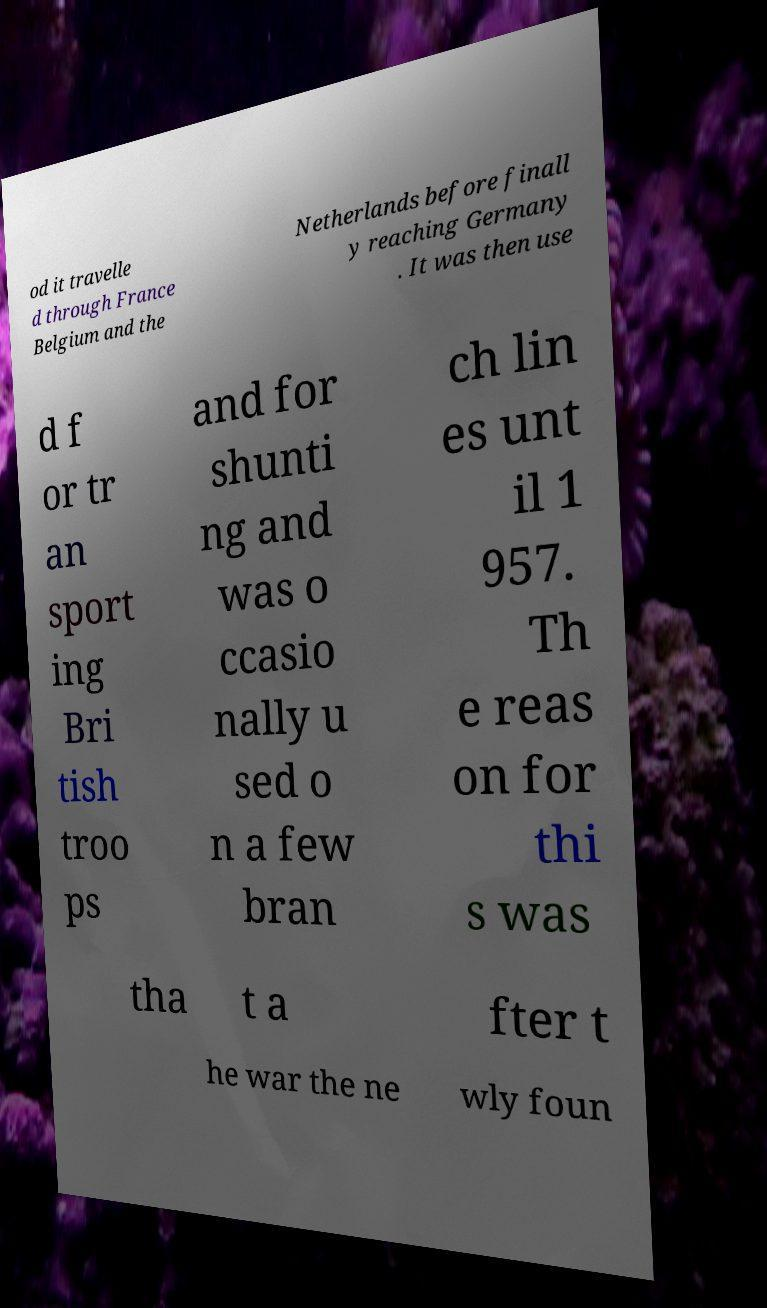Please identify and transcribe the text found in this image. od it travelle d through France Belgium and the Netherlands before finall y reaching Germany . It was then use d f or tr an sport ing Bri tish troo ps and for shunti ng and was o ccasio nally u sed o n a few bran ch lin es unt il 1 957. Th e reas on for thi s was tha t a fter t he war the ne wly foun 